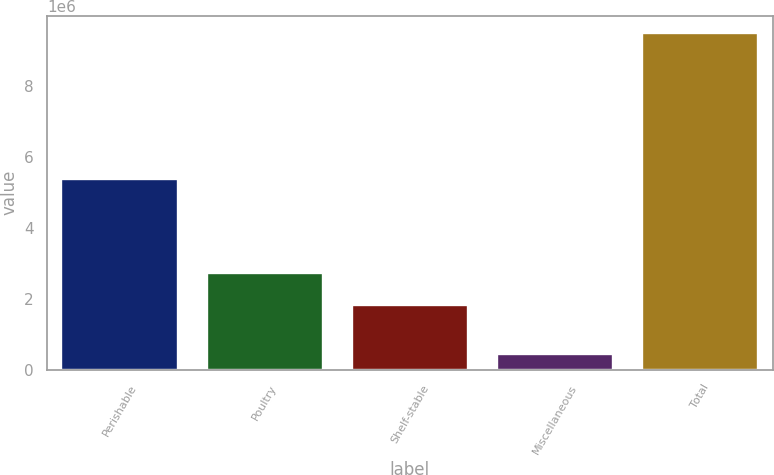Convert chart. <chart><loc_0><loc_0><loc_500><loc_500><bar_chart><fcel>Perishable<fcel>Poultry<fcel>Shelf-stable<fcel>Miscellaneous<fcel>Total<nl><fcel>5.37041e+06<fcel>2.73402e+06<fcel>1.82914e+06<fcel>448476<fcel>9.49732e+06<nl></chart> 